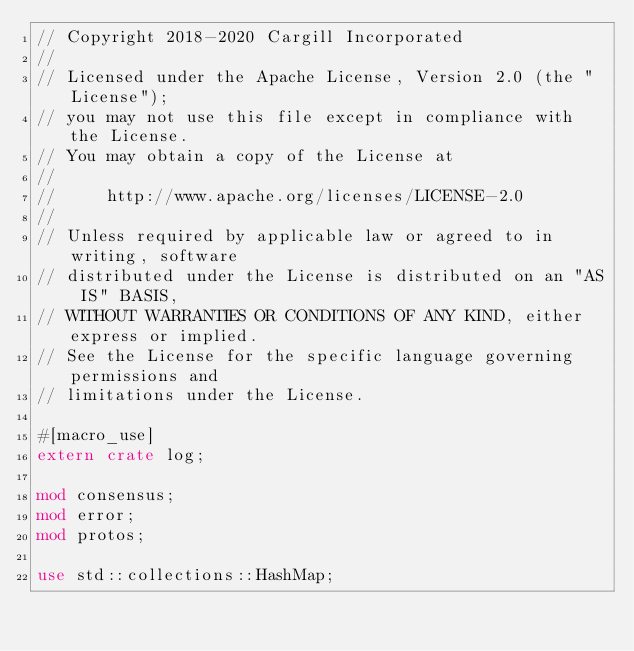Convert code to text. <code><loc_0><loc_0><loc_500><loc_500><_Rust_>// Copyright 2018-2020 Cargill Incorporated
//
// Licensed under the Apache License, Version 2.0 (the "License");
// you may not use this file except in compliance with the License.
// You may obtain a copy of the License at
//
//     http://www.apache.org/licenses/LICENSE-2.0
//
// Unless required by applicable law or agreed to in writing, software
// distributed under the License is distributed on an "AS IS" BASIS,
// WITHOUT WARRANTIES OR CONDITIONS OF ANY KIND, either express or implied.
// See the License for the specific language governing permissions and
// limitations under the License.

#[macro_use]
extern crate log;

mod consensus;
mod error;
mod protos;

use std::collections::HashMap;</code> 